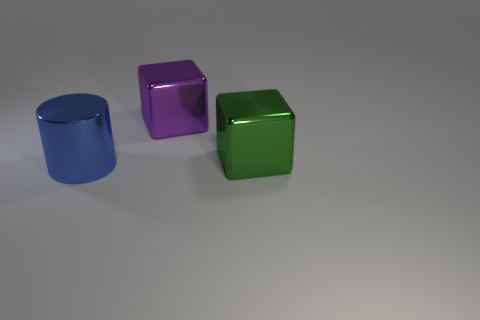What is the size of the metal cylinder?
Provide a short and direct response. Large. What material is the green thing that is the same size as the blue metallic thing?
Ensure brevity in your answer.  Metal. The large metallic block that is left of the green shiny cube is what color?
Make the answer very short. Purple. What number of cyan rubber balls are there?
Your answer should be very brief. 0. Are there any purple metal objects that are in front of the metallic thing right of the shiny cube that is left of the large green shiny cube?
Make the answer very short. No. What shape is the green metal thing that is the same size as the purple cube?
Keep it short and to the point. Cube. What is the material of the big purple cube?
Provide a succinct answer. Metal. How many other objects are the same material as the large purple thing?
Your answer should be very brief. 2. What is the size of the thing that is left of the green cube and behind the blue shiny object?
Give a very brief answer. Large. There is a large shiny thing that is on the left side of the object that is behind the green shiny block; what shape is it?
Offer a terse response. Cylinder. 